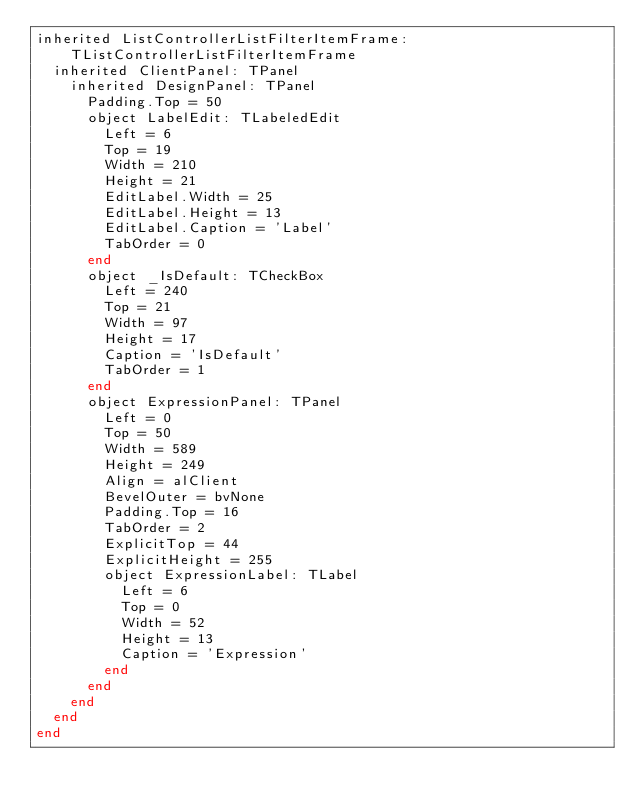<code> <loc_0><loc_0><loc_500><loc_500><_Pascal_>inherited ListControllerListFilterItemFrame: TListControllerListFilterItemFrame
  inherited ClientPanel: TPanel
    inherited DesignPanel: TPanel
      Padding.Top = 50
      object LabelEdit: TLabeledEdit
        Left = 6
        Top = 19
        Width = 210
        Height = 21
        EditLabel.Width = 25
        EditLabel.Height = 13
        EditLabel.Caption = 'Label'
        TabOrder = 0
      end
      object _IsDefault: TCheckBox
        Left = 240
        Top = 21
        Width = 97
        Height = 17
        Caption = 'IsDefault'
        TabOrder = 1
      end
      object ExpressionPanel: TPanel
        Left = 0
        Top = 50
        Width = 589
        Height = 249
        Align = alClient
        BevelOuter = bvNone
        Padding.Top = 16
        TabOrder = 2
        ExplicitTop = 44
        ExplicitHeight = 255
        object ExpressionLabel: TLabel
          Left = 6
          Top = 0
          Width = 52
          Height = 13
          Caption = 'Expression'
        end
      end
    end
  end
end
</code> 